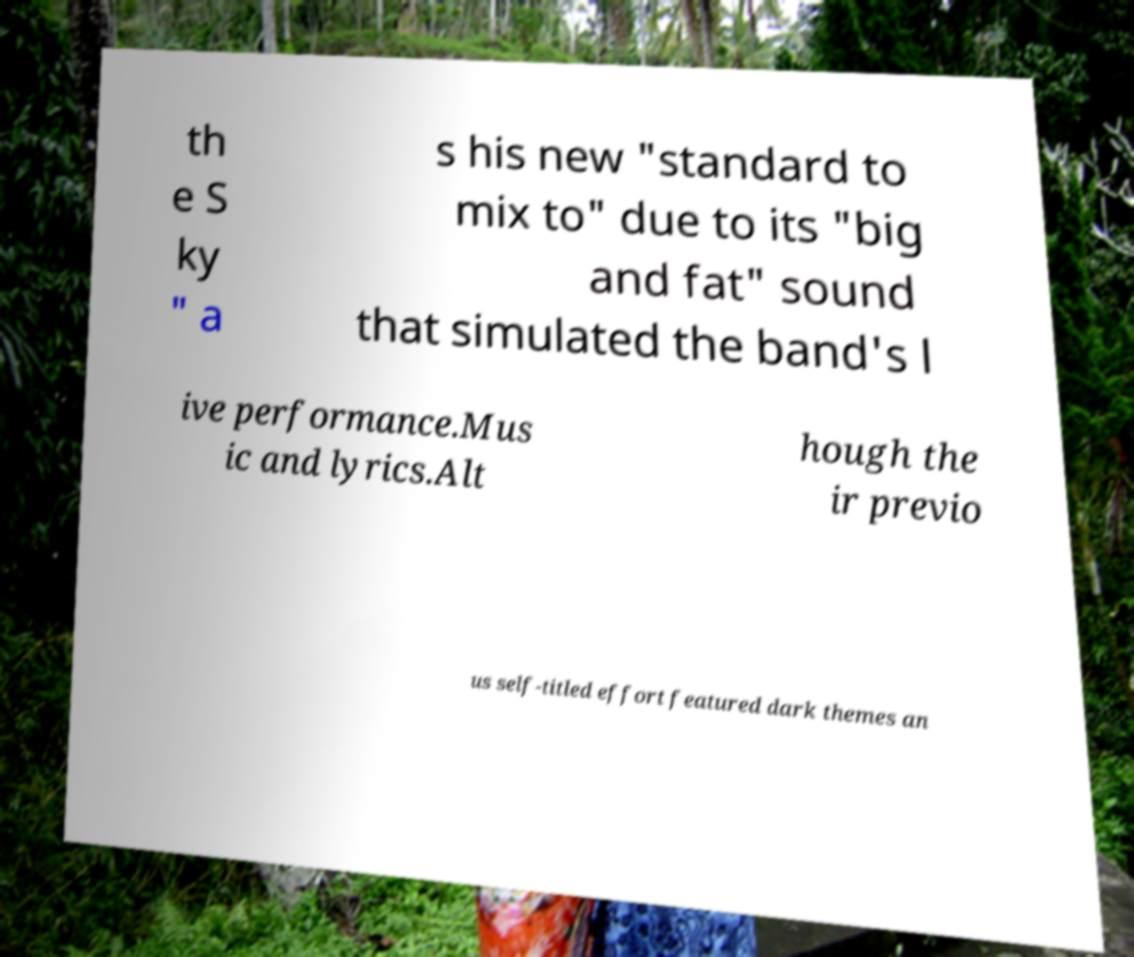There's text embedded in this image that I need extracted. Can you transcribe it verbatim? th e S ky " a s his new "standard to mix to" due to its "big and fat" sound that simulated the band's l ive performance.Mus ic and lyrics.Alt hough the ir previo us self-titled effort featured dark themes an 